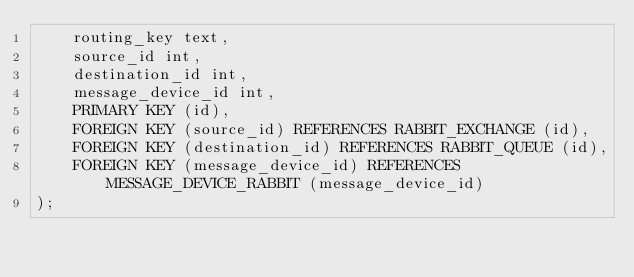Convert code to text. <code><loc_0><loc_0><loc_500><loc_500><_SQL_>    routing_key text,
    source_id int,
    destination_id int,
    message_device_id int,
    PRIMARY KEY (id),
    FOREIGN KEY (source_id) REFERENCES RABBIT_EXCHANGE (id),
    FOREIGN KEY (destination_id) REFERENCES RABBIT_QUEUE (id),
    FOREIGN KEY (message_device_id) REFERENCES MESSAGE_DEVICE_RABBIT (message_device_id)
);</code> 